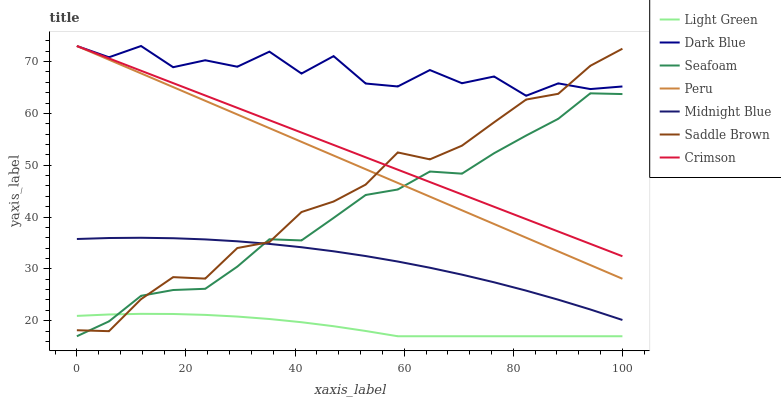Does Light Green have the minimum area under the curve?
Answer yes or no. Yes. Does Dark Blue have the maximum area under the curve?
Answer yes or no. Yes. Does Seafoam have the minimum area under the curve?
Answer yes or no. No. Does Seafoam have the maximum area under the curve?
Answer yes or no. No. Is Peru the smoothest?
Answer yes or no. Yes. Is Dark Blue the roughest?
Answer yes or no. Yes. Is Seafoam the smoothest?
Answer yes or no. No. Is Seafoam the roughest?
Answer yes or no. No. Does Light Green have the lowest value?
Answer yes or no. Yes. Does Dark Blue have the lowest value?
Answer yes or no. No. Does Crimson have the highest value?
Answer yes or no. Yes. Does Seafoam have the highest value?
Answer yes or no. No. Is Light Green less than Midnight Blue?
Answer yes or no. Yes. Is Dark Blue greater than Light Green?
Answer yes or no. Yes. Does Crimson intersect Dark Blue?
Answer yes or no. Yes. Is Crimson less than Dark Blue?
Answer yes or no. No. Is Crimson greater than Dark Blue?
Answer yes or no. No. Does Light Green intersect Midnight Blue?
Answer yes or no. No. 